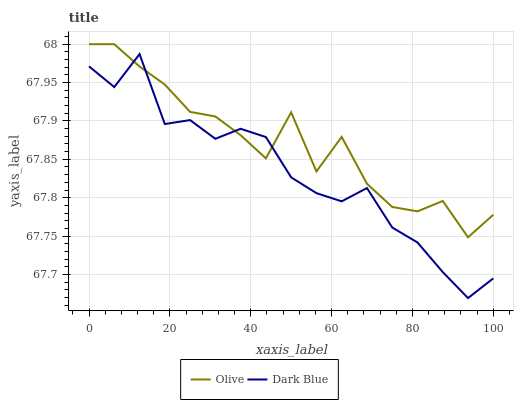Does Dark Blue have the minimum area under the curve?
Answer yes or no. Yes. Does Olive have the maximum area under the curve?
Answer yes or no. Yes. Does Dark Blue have the maximum area under the curve?
Answer yes or no. No. Is Dark Blue the smoothest?
Answer yes or no. Yes. Is Olive the roughest?
Answer yes or no. Yes. Is Dark Blue the roughest?
Answer yes or no. No. Does Olive have the highest value?
Answer yes or no. Yes. Does Dark Blue have the highest value?
Answer yes or no. No. Does Dark Blue intersect Olive?
Answer yes or no. Yes. Is Dark Blue less than Olive?
Answer yes or no. No. Is Dark Blue greater than Olive?
Answer yes or no. No. 